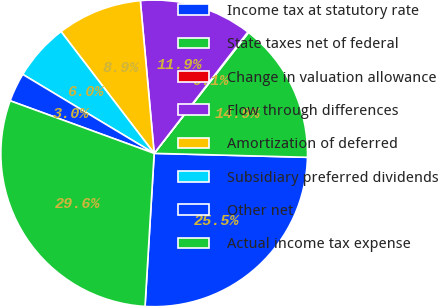<chart> <loc_0><loc_0><loc_500><loc_500><pie_chart><fcel>Income tax at statutory rate<fcel>State taxes net of federal<fcel>Change in valuation allowance<fcel>Flow through differences<fcel>Amortization of deferred<fcel>Subsidiary preferred dividends<fcel>Other net<fcel>Actual income tax expense<nl><fcel>25.54%<fcel>14.86%<fcel>0.09%<fcel>11.9%<fcel>8.95%<fcel>6.0%<fcel>3.04%<fcel>29.62%<nl></chart> 